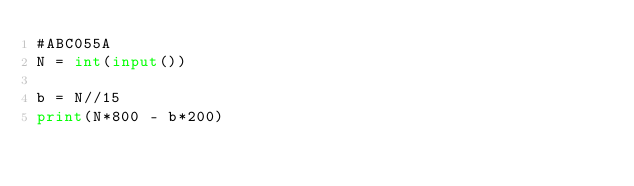Convert code to text. <code><loc_0><loc_0><loc_500><loc_500><_Python_>#ABC055A
N = int(input())

b = N//15
print(N*800 - b*200)</code> 